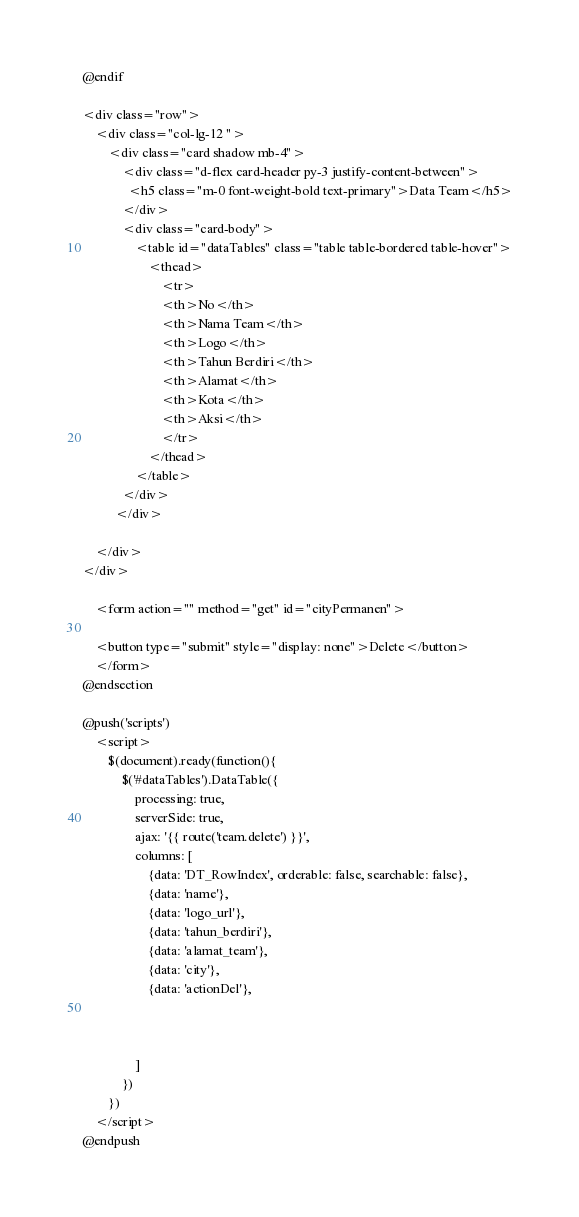Convert code to text. <code><loc_0><loc_0><loc_500><loc_500><_PHP_>@endif

<div class="row">
    <div class="col-lg-12 ">
        <div class="card shadow mb-4">
            <div class="d-flex card-header py-3 justify-content-between">
              <h5 class="m-0 font-weight-bold text-primary">Data Team</h5>
            </div>
            <div class="card-body">
                <table id="dataTables" class="table table-bordered table-hover">
                    <thead>
                        <tr>
                        <th>No</th>
                        <th>Nama Team</th>
                        <th>Logo</th>
                        <th>Tahun Berdiri</th>
                        <th>Alamat</th>
                        <th>Kota</th>
                        <th>Aksi</th>
                        </tr>
                    </thead>
                </table>
            </div>
          </div>

    </div>
</div>
   
    <form action="" method="get" id="cityPermanen">
        
    <button type="submit" style="display: none">Delete</button>
    </form>
@endsection

@push('scripts')
    <script>
        $(document).ready(function(){
            $('#dataTables').DataTable({
                processing: true,
                serverSide: true,
                ajax: '{{ route('team.delete') }}',
                columns: [
                    {data: 'DT_RowIndex', orderable: false, searchable: false},
                    {data: 'name'},
                    {data: 'logo_url'},
                    {data: 'tahun_berdiri'},
                    {data: 'alamat_team'},
                    {data: 'city'},
                    {data: 'actionDel'},



                ]
            })
        })
    </script>
@endpush</code> 